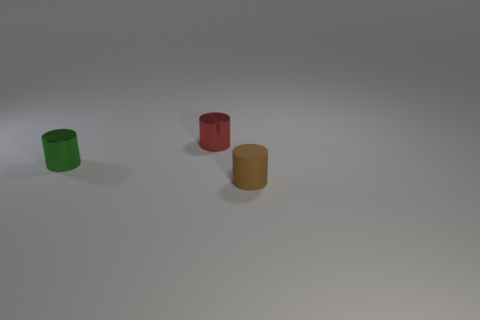Add 1 purple metal cylinders. How many objects exist? 4 Add 1 small red metallic objects. How many small red metallic objects are left? 2 Add 3 large blue balls. How many large blue balls exist? 3 Subtract 0 yellow blocks. How many objects are left? 3 Subtract all small cyan spheres. Subtract all green metal cylinders. How many objects are left? 2 